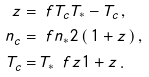<formula> <loc_0><loc_0><loc_500><loc_500>z = & \, \ f { T _ { c } } { T _ { * } - T _ { c } } \, , \\ n _ { c } = & \, \ f { n _ { * } } { 2 \left ( \, 1 + z \, \right ) } \, , \\ T _ { c } = & \, T _ { * } \, \ f { z } { 1 + z } \, .</formula> 